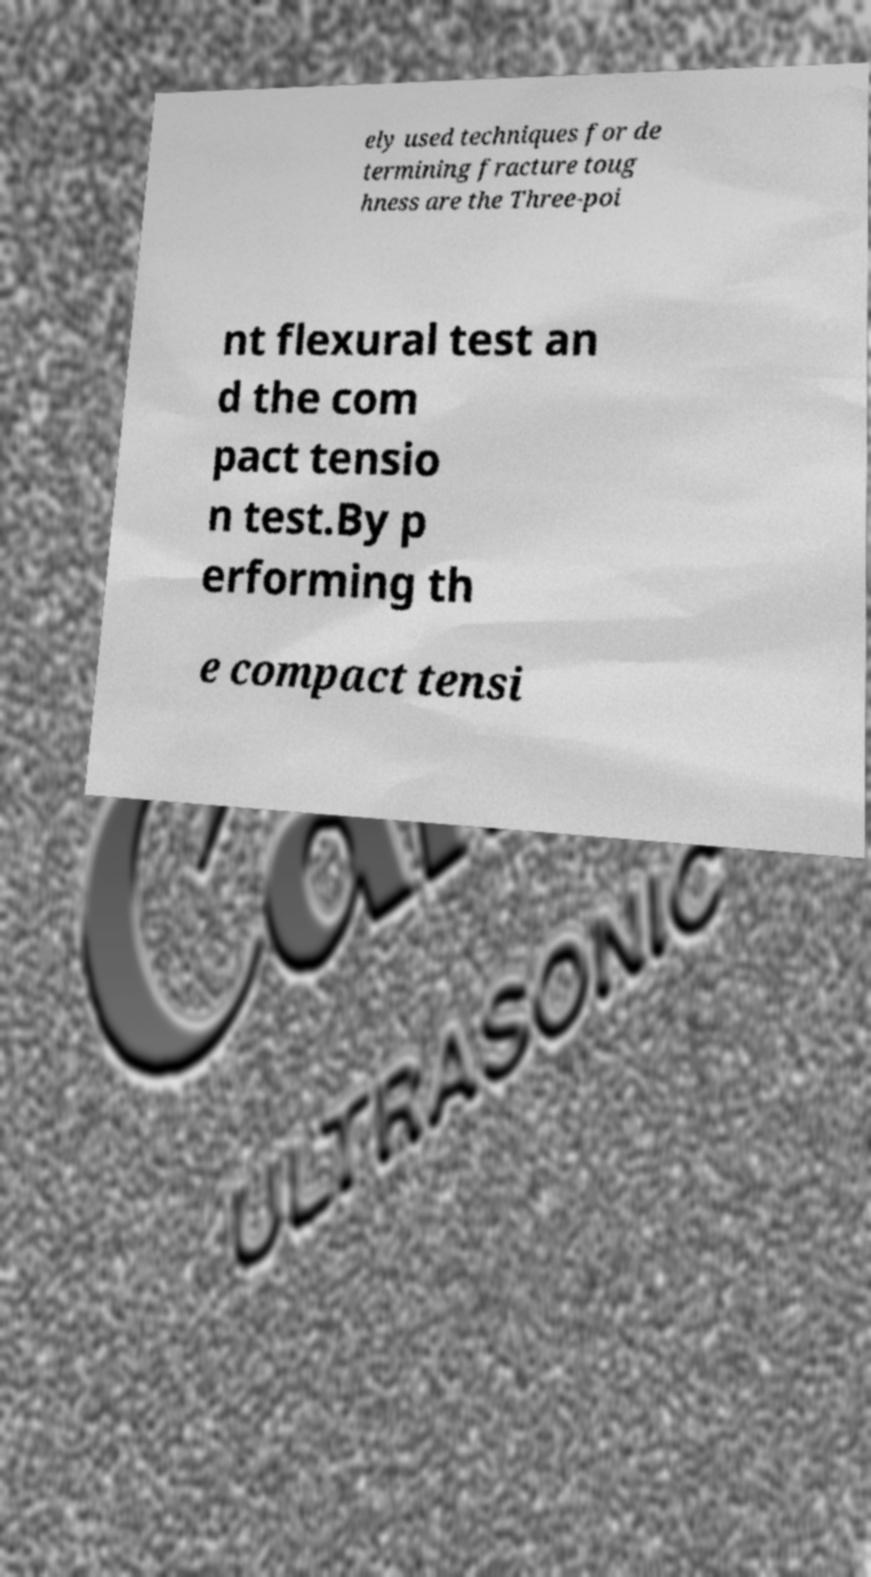For documentation purposes, I need the text within this image transcribed. Could you provide that? ely used techniques for de termining fracture toug hness are the Three-poi nt flexural test an d the com pact tensio n test.By p erforming th e compact tensi 